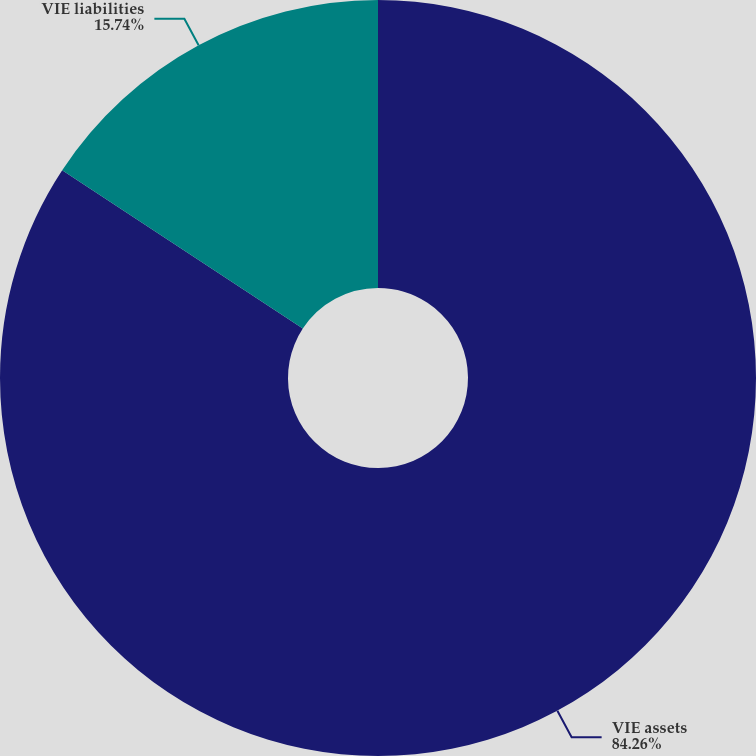Convert chart to OTSL. <chart><loc_0><loc_0><loc_500><loc_500><pie_chart><fcel>VIE assets<fcel>VIE liabilities<nl><fcel>84.26%<fcel>15.74%<nl></chart> 